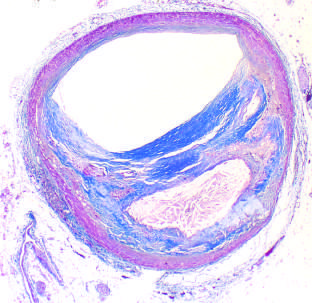what is moderately narrowed by this eccentric lesion?
Answer the question using a single word or phrase. The lumen 